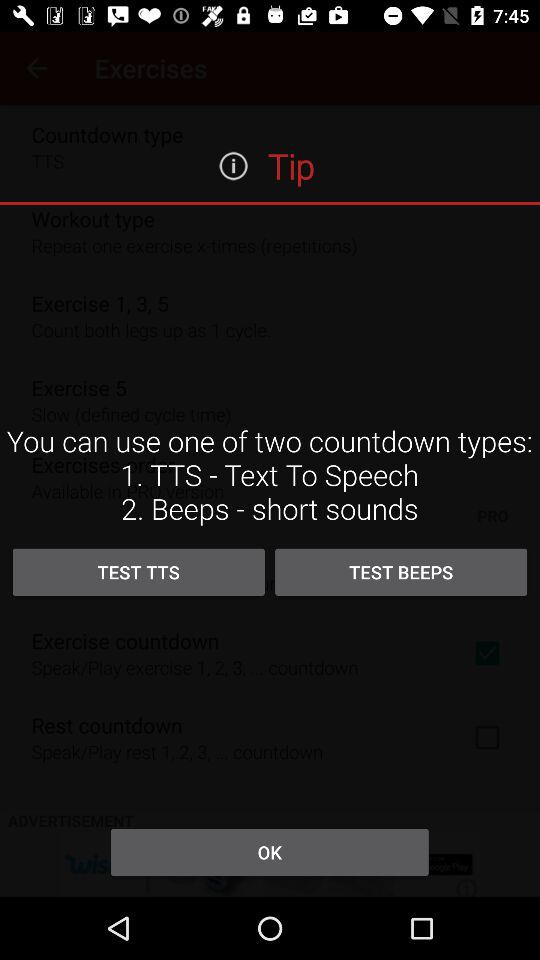How long is the countdown?
When the provided information is insufficient, respond with <no answer>. <no answer> 